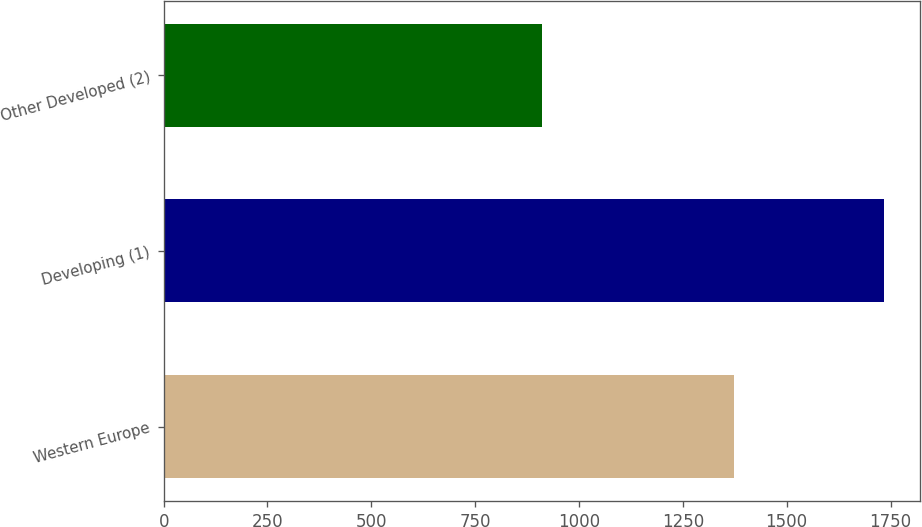Convert chart to OTSL. <chart><loc_0><loc_0><loc_500><loc_500><bar_chart><fcel>Western Europe<fcel>Developing (1)<fcel>Other Developed (2)<nl><fcel>1373.8<fcel>1733.8<fcel>910.4<nl></chart> 